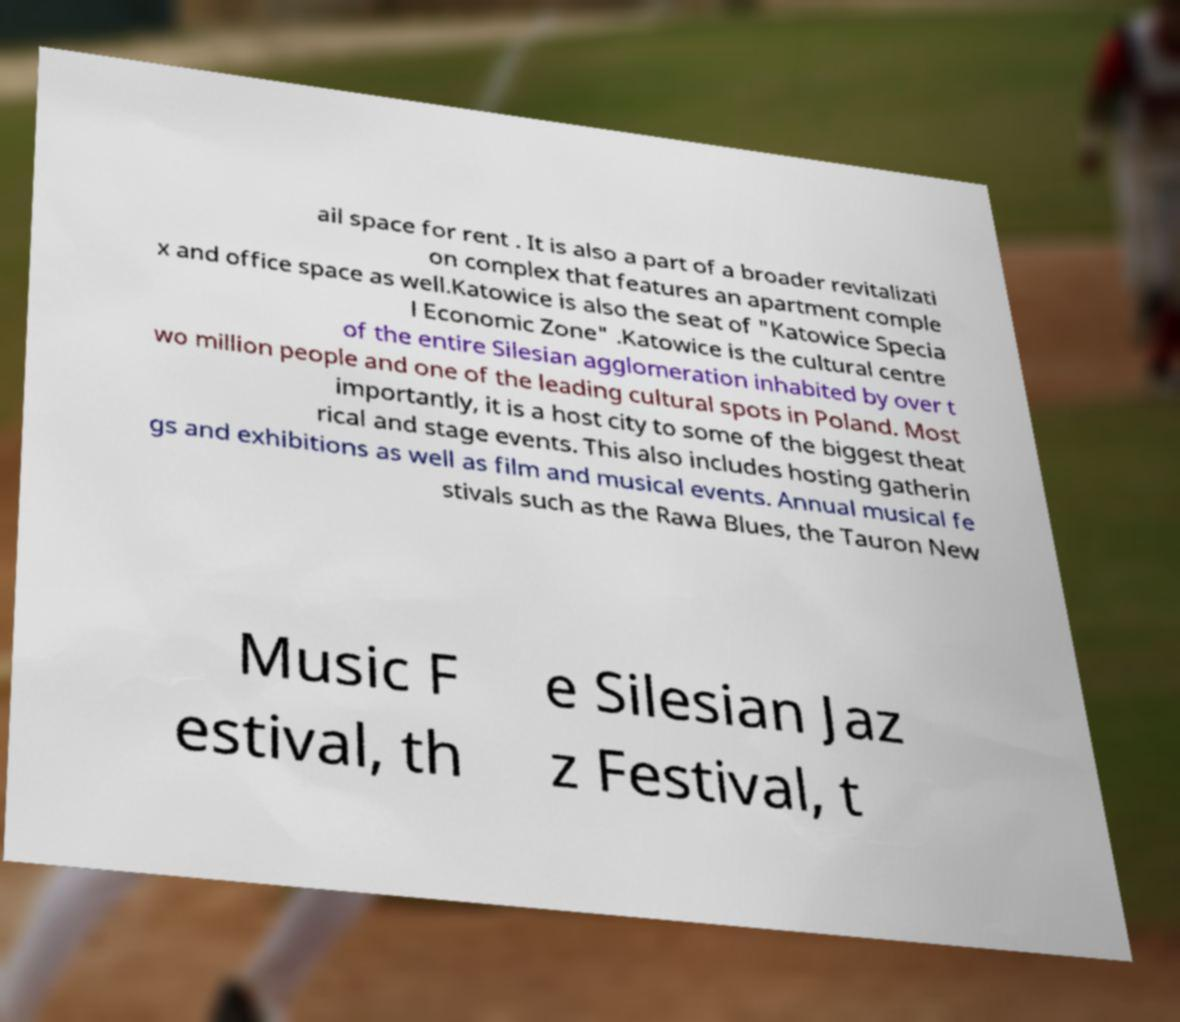What messages or text are displayed in this image? I need them in a readable, typed format. ail space for rent . It is also a part of a broader revitalizati on complex that features an apartment comple x and office space as well.Katowice is also the seat of "Katowice Specia l Economic Zone" .Katowice is the cultural centre of the entire Silesian agglomeration inhabited by over t wo million people and one of the leading cultural spots in Poland. Most importantly, it is a host city to some of the biggest theat rical and stage events. This also includes hosting gatherin gs and exhibitions as well as film and musical events. Annual musical fe stivals such as the Rawa Blues, the Tauron New Music F estival, th e Silesian Jaz z Festival, t 